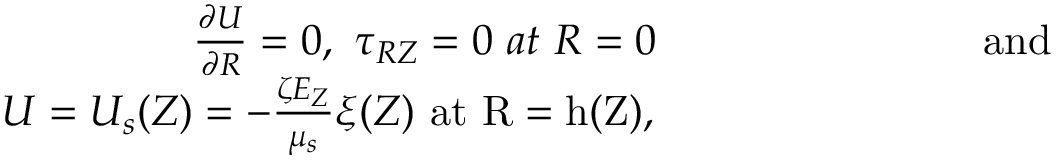<formula> <loc_0><loc_0><loc_500><loc_500>\begin{array} { r } { \frac { \partial U } { \partial R } = 0 , \tau _ { R Z } = 0 a t R = 0 { a n d } } \\ { U = U _ { s } ( Z ) = - \frac { \zeta E _ { Z } } { \mu _ { s } } \xi ( Z ) { a t } R = h ( Z ) , } \end{array}</formula> 